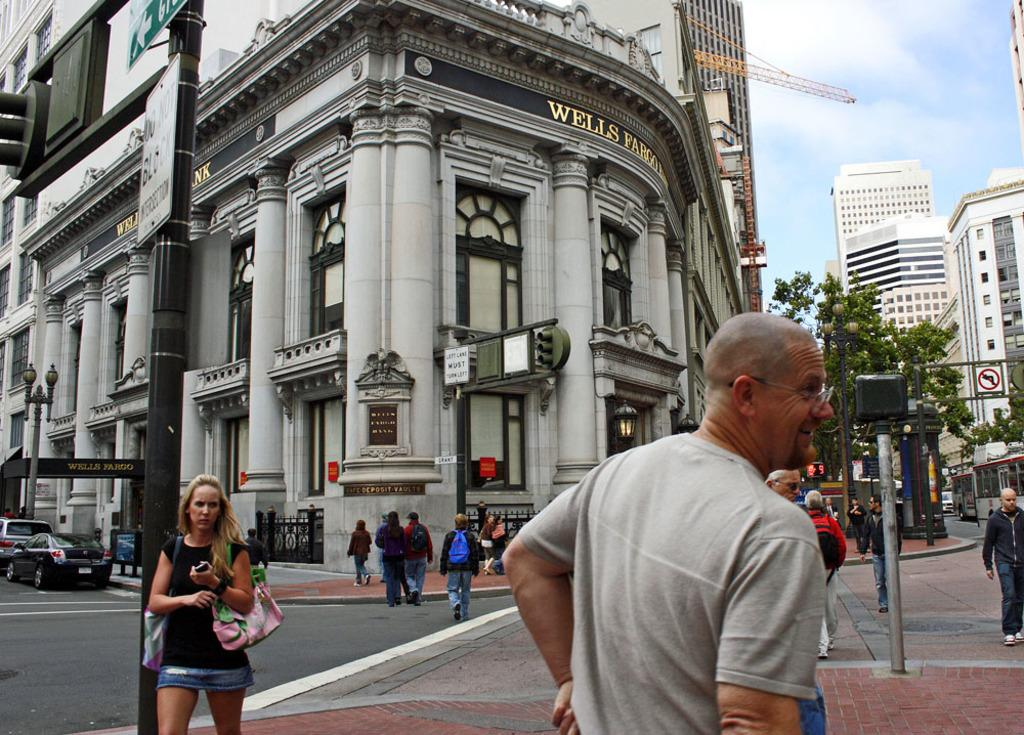Who or what can be seen in the image? There are people in the image. What objects are present in the image? There are boards, lights, traffic signals on poles, and vehicles on the road in the image. What structures are visible in the background of the image? There are buildings, a crane, and trees in the background of the image. What part of the natural environment is visible in the image? The sky is visible in the background of the image. What sense does the crow use to navigate the image? There is no crow present in the image, so it is not possible to determine which sense it might use to navigate. How does the crane pull the vehicles in the image? The crane is not pulling any vehicles in the image; it is stationary in the background. 